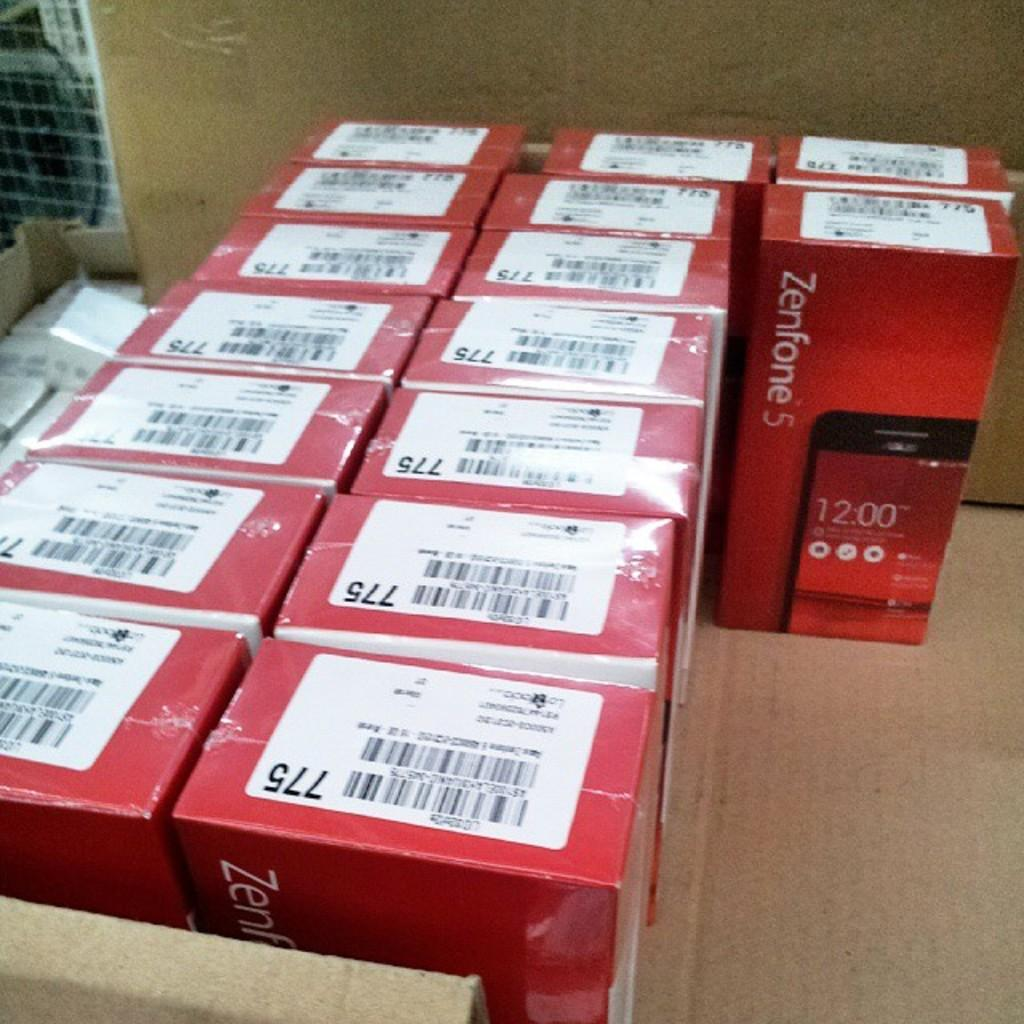<image>
Describe the image concisely. Red boxes are lined up and labeled with the number 775. 